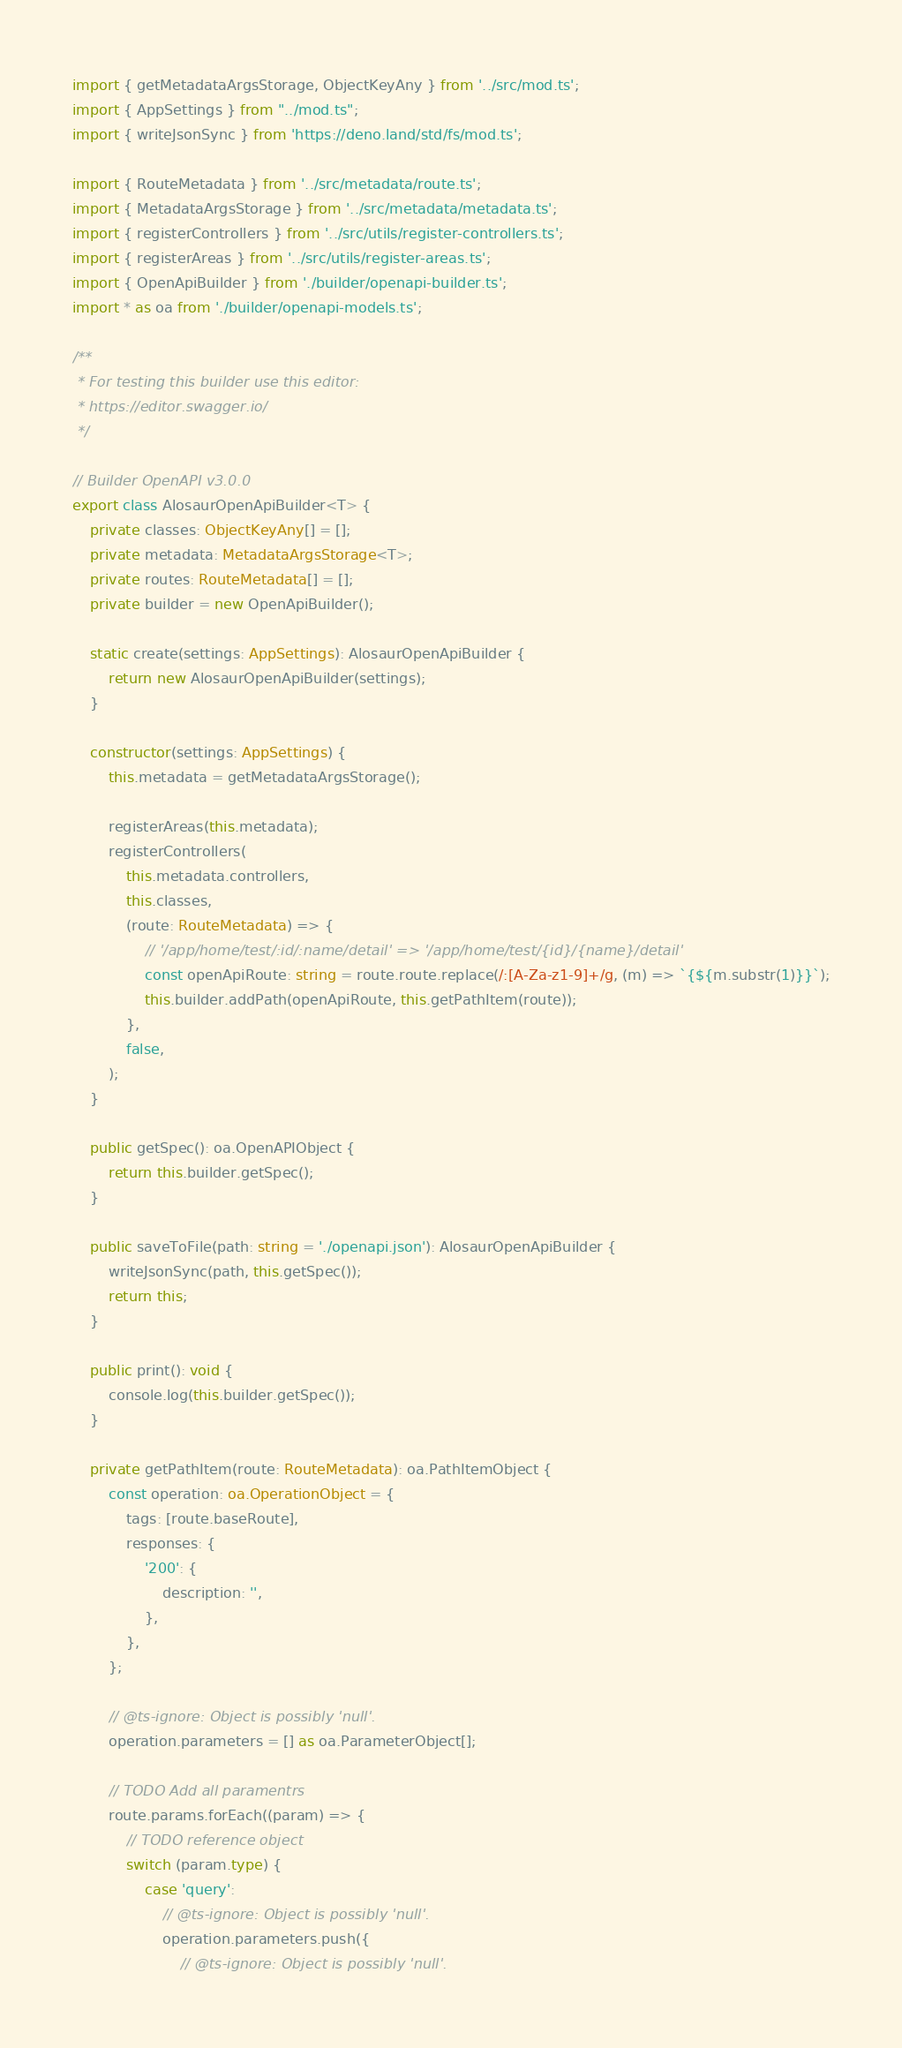Convert code to text. <code><loc_0><loc_0><loc_500><loc_500><_TypeScript_>import { getMetadataArgsStorage, ObjectKeyAny } from '../src/mod.ts';
import { AppSettings } from "../mod.ts";
import { writeJsonSync } from 'https://deno.land/std/fs/mod.ts';

import { RouteMetadata } from '../src/metadata/route.ts';
import { MetadataArgsStorage } from '../src/metadata/metadata.ts';
import { registerControllers } from '../src/utils/register-controllers.ts';
import { registerAreas } from '../src/utils/register-areas.ts';
import { OpenApiBuilder } from './builder/openapi-builder.ts';
import * as oa from './builder/openapi-models.ts';

/**
 * For testing this builder use this editor:
 * https://editor.swagger.io/
 */

// Builder OpenAPI v3.0.0
export class AlosaurOpenApiBuilder<T> {
    private classes: ObjectKeyAny[] = [];
    private metadata: MetadataArgsStorage<T>;
    private routes: RouteMetadata[] = [];
    private builder = new OpenApiBuilder();

    static create(settings: AppSettings): AlosaurOpenApiBuilder {
        return new AlosaurOpenApiBuilder(settings);
    }

    constructor(settings: AppSettings) {
        this.metadata = getMetadataArgsStorage();

        registerAreas(this.metadata);
        registerControllers(
            this.metadata.controllers,
            this.classes,
            (route: RouteMetadata) => {
                // '/app/home/test/:id/:name/detail' => '/app/home/test/{id}/{name}/detail'
                const openApiRoute: string = route.route.replace(/:[A-Za-z1-9]+/g, (m) => `{${m.substr(1)}}`);
                this.builder.addPath(openApiRoute, this.getPathItem(route));
            },
            false,
        );
    }

    public getSpec(): oa.OpenAPIObject {
        return this.builder.getSpec();
    }

    public saveToFile(path: string = './openapi.json'): AlosaurOpenApiBuilder {
        writeJsonSync(path, this.getSpec());
        return this;
    }

    public print(): void {
        console.log(this.builder.getSpec());
    }

    private getPathItem(route: RouteMetadata): oa.PathItemObject {
        const operation: oa.OperationObject = {
            tags: [route.baseRoute],
            responses: {
                '200': {
                    description: '',
                },
            },
        };

        // @ts-ignore: Object is possibly 'null'.
        operation.parameters = [] as oa.ParameterObject[];

        // TODO Add all paramentrs
        route.params.forEach((param) => {
            // TODO reference object
            switch (param.type) {
                case 'query':
                    // @ts-ignore: Object is possibly 'null'.
                    operation.parameters.push({
                        // @ts-ignore: Object is possibly 'null'.</code> 